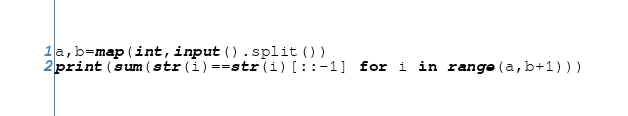<code> <loc_0><loc_0><loc_500><loc_500><_Python_>a,b=map(int,input().split())
print(sum(str(i)==str(i)[::-1] for i in range(a,b+1)))</code> 